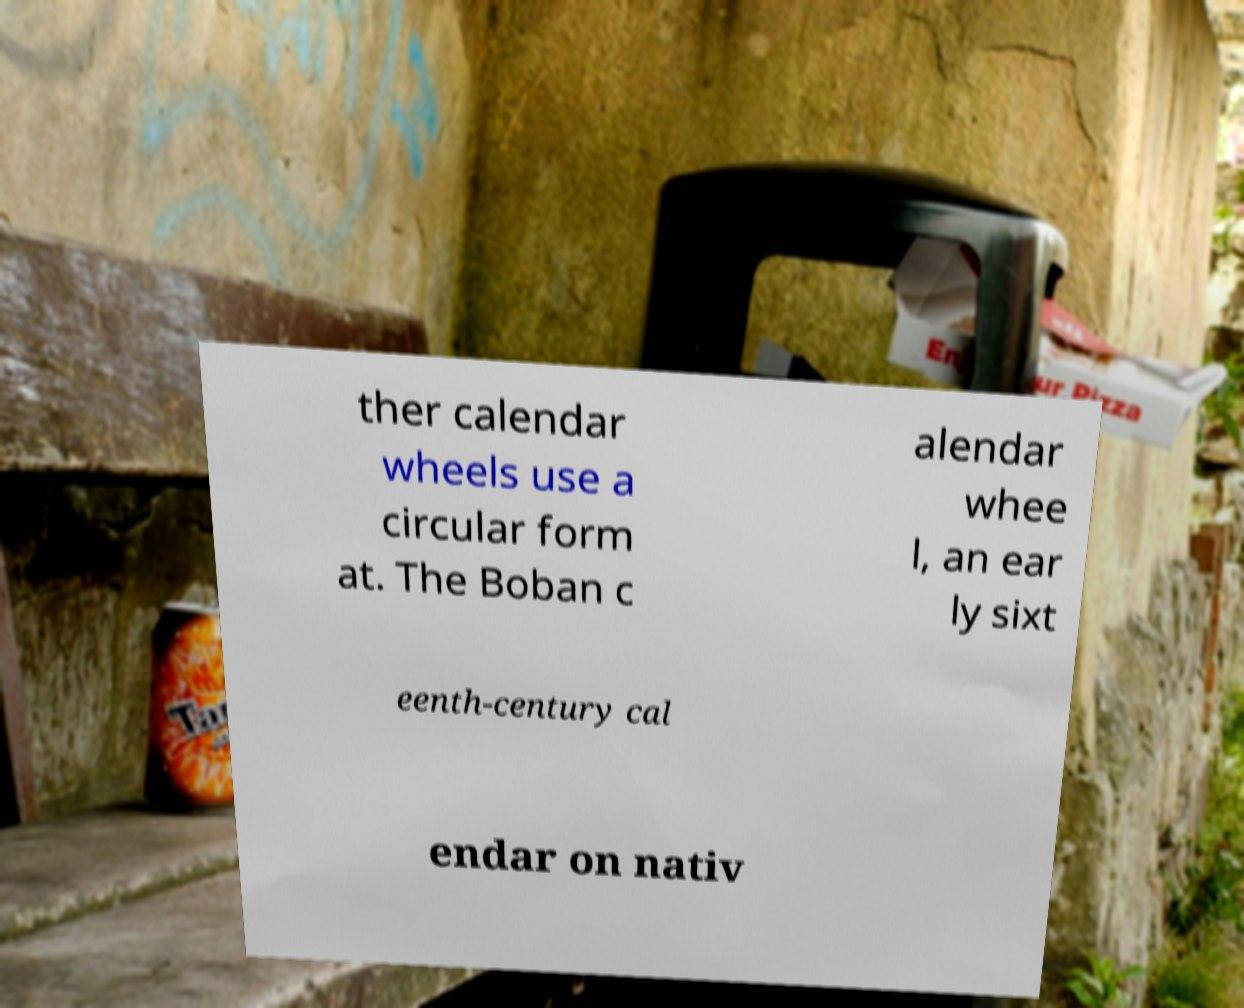Could you assist in decoding the text presented in this image and type it out clearly? ther calendar wheels use a circular form at. The Boban c alendar whee l, an ear ly sixt eenth-century cal endar on nativ 